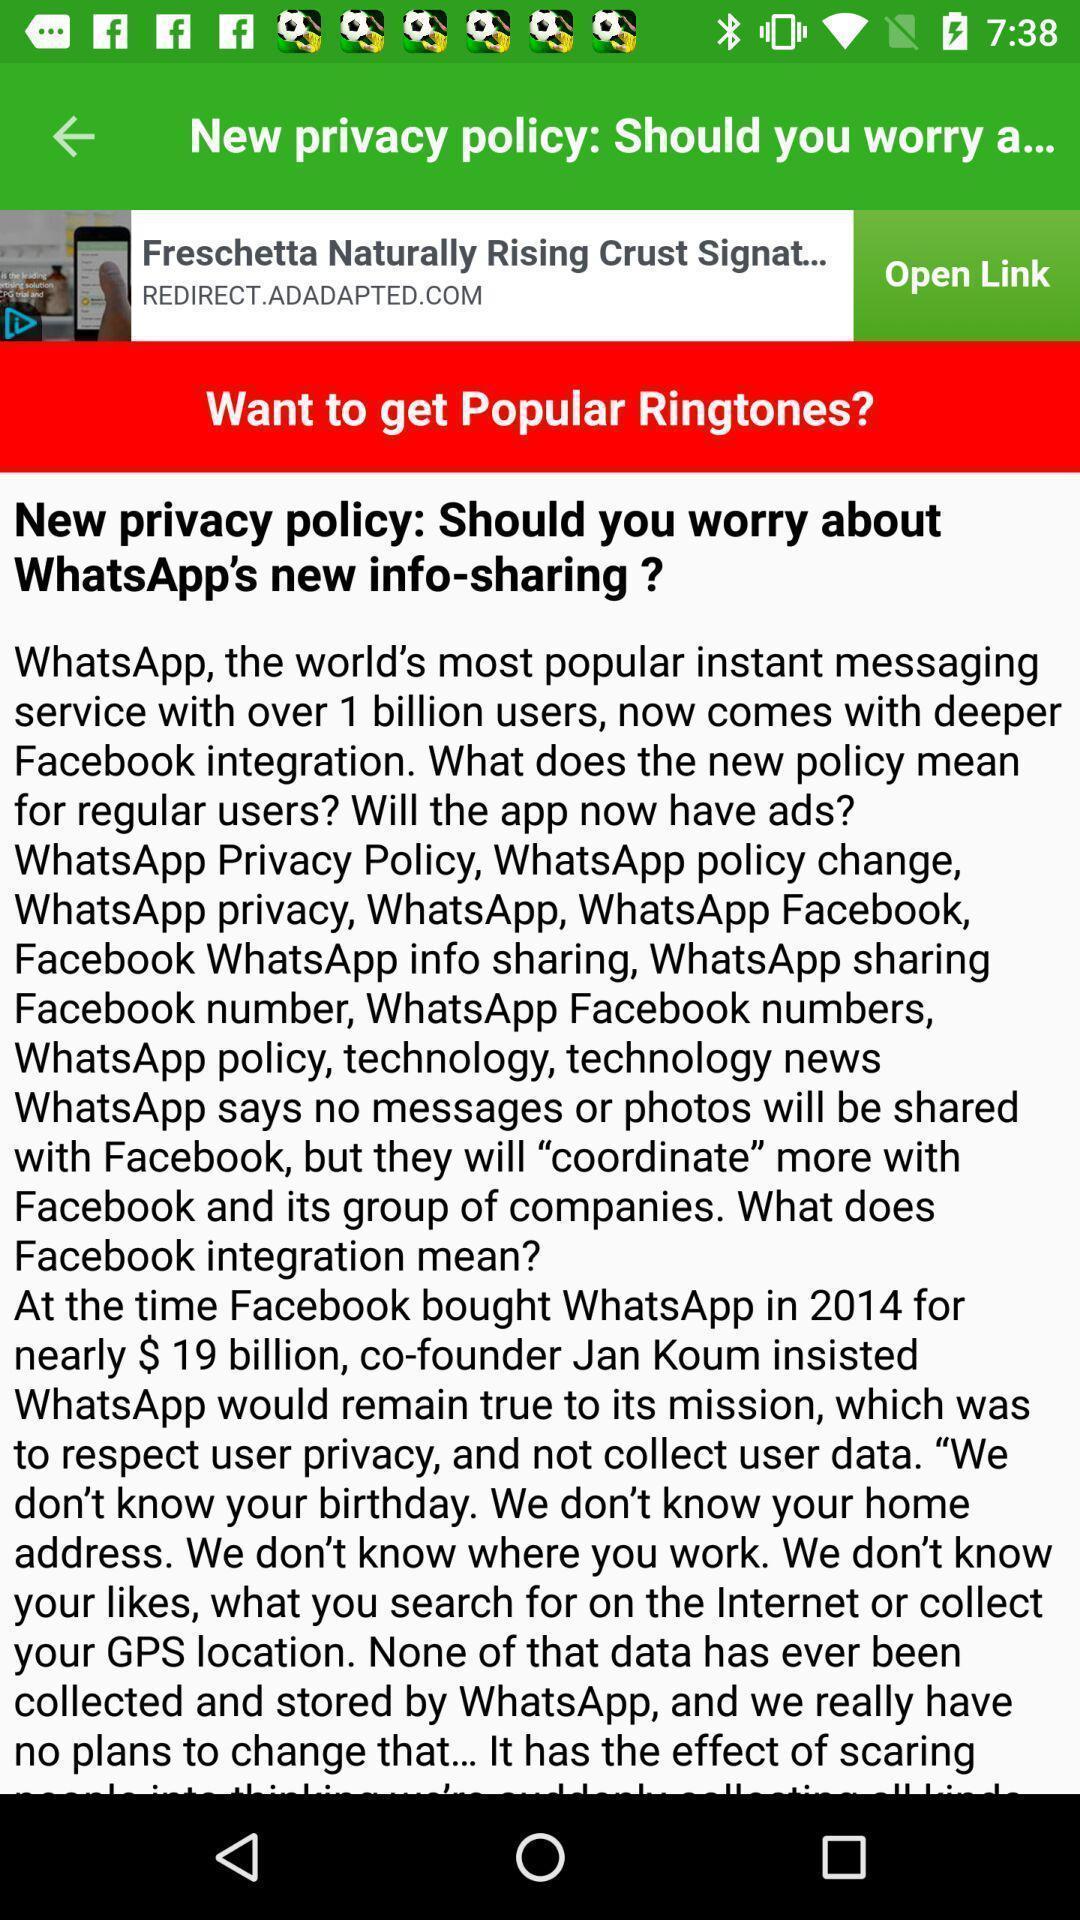Describe this image in words. Privacy policy page. 